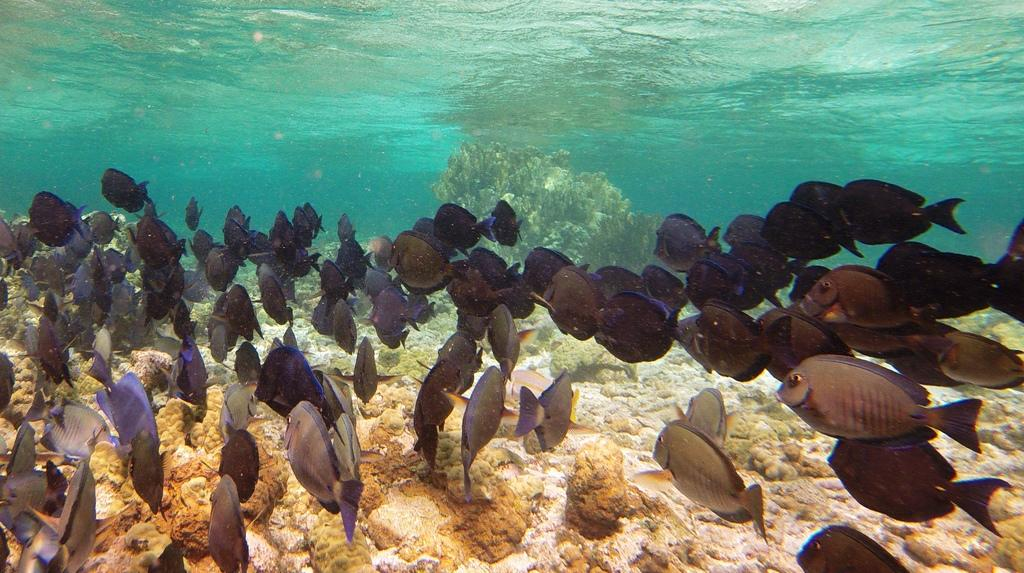What type of animals can be seen in the image? There are fishes in the image. Where are the fishes located? The fishes are in the water. What type of kite is being flown by the company in the image? There is no kite or company present in the image; it features fishes in the water. How many drops of water can be seen falling from the fishes in the image? There is no mention of water droplets or any other liquid in the image; it only shows fishes in the water. 